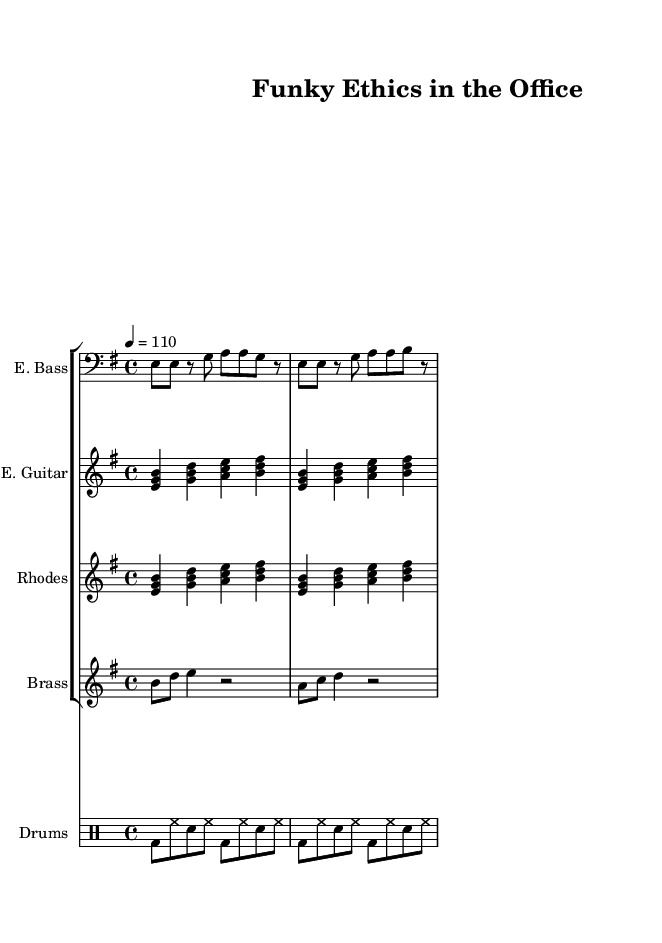What is the key signature of this music? The key signature consists of one sharp, which corresponds to E minor or G major. Therefore, the key signature is E minor.
Answer: E minor What is the time signature of this music? The time signature is indicated at the beginning of the score and is 4 over 4, which signifies four beats in each measure.
Answer: 4/4 What is the tempo marking for this piece? The tempo marking indicates that the piece should be played at a speed of 110 beats per minute.
Answer: 110 How many instruments are included in the score? The score features a total of five instruments: electric bass, electric guitar, Rhodes piano, brass section, and drums. Counting each provides the sum.
Answer: Five Which instrument plays the first note in the score? The electric bass part starts with the note E on the first beat of the first measure, indicating it is the instrument that plays first.
Answer: Electric bass What is the rhythmic pattern of the drum kit? The drum kit uses a consistent pattern throughout the measures, alternating between bass drum and snare drum amidst hi-hat beats. This repeated sequence establishes a funk groove.
Answer: Alternating bass and snare How does the brass section contribute to the funk feel of this piece? The brass section introduces syncopated rhythms and accents, typical in funk music, which creates a lively and dynamic atmosphere. The specific notes are a mix of eighths and quarters, adding to the groove.
Answer: Syncopated rhythms 